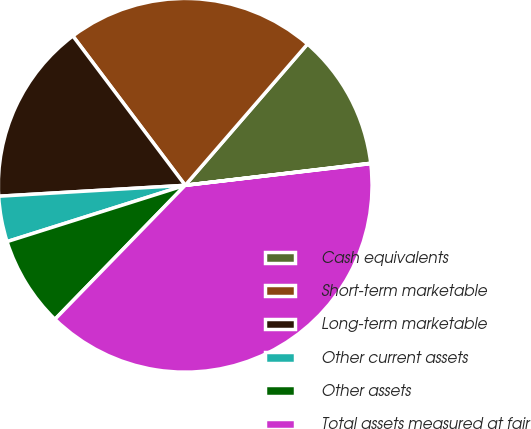<chart> <loc_0><loc_0><loc_500><loc_500><pie_chart><fcel>Cash equivalents<fcel>Short-term marketable<fcel>Long-term marketable<fcel>Other current assets<fcel>Other assets<fcel>Total assets measured at fair<fcel>Other current liabilities<nl><fcel>11.76%<fcel>21.62%<fcel>15.67%<fcel>3.94%<fcel>7.85%<fcel>39.13%<fcel>0.03%<nl></chart> 